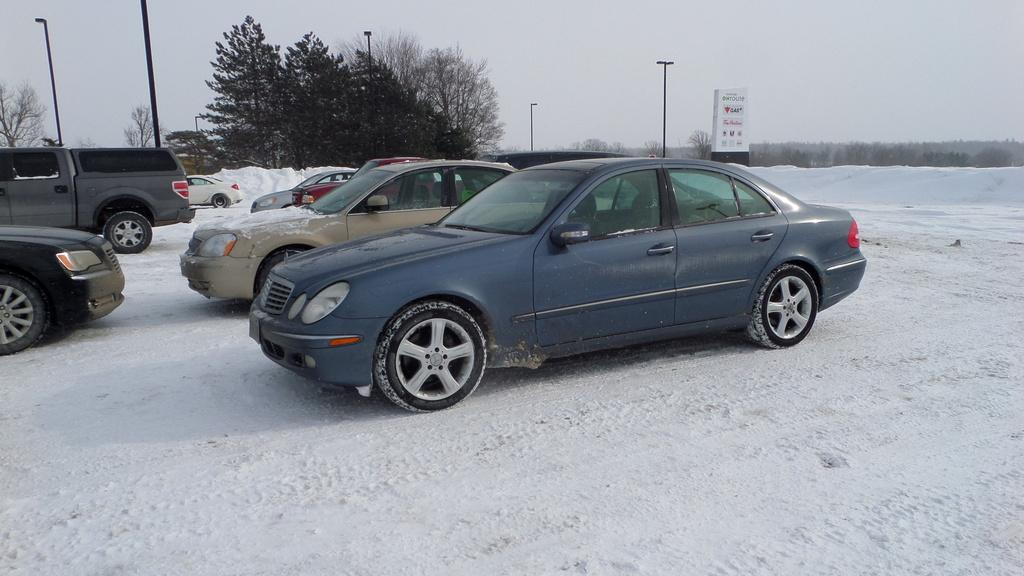What can be seen in the image? There are vehicles in the image. Can you describe the vehicles? The vehicles are in different colors. What is the setting of the image? The vehicles are on snow. What can be seen in the background of the image? There are poles, trees, boards, and the sky visible in the background of the image. What type of wave can be seen crashing on the shore in the image? There is no wave or shore present in the image; it features vehicles on snow with a background that includes poles, trees, boards, and the sky. 